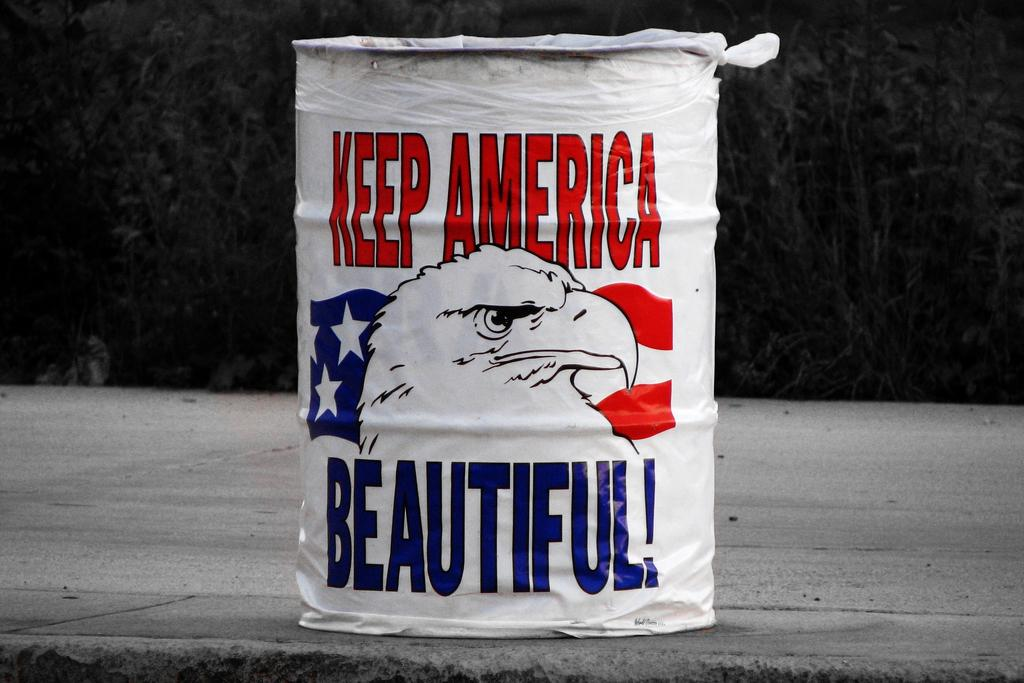<image>
Present a compact description of the photo's key features. Garbage can painted with Keep America Beautiful on it. 